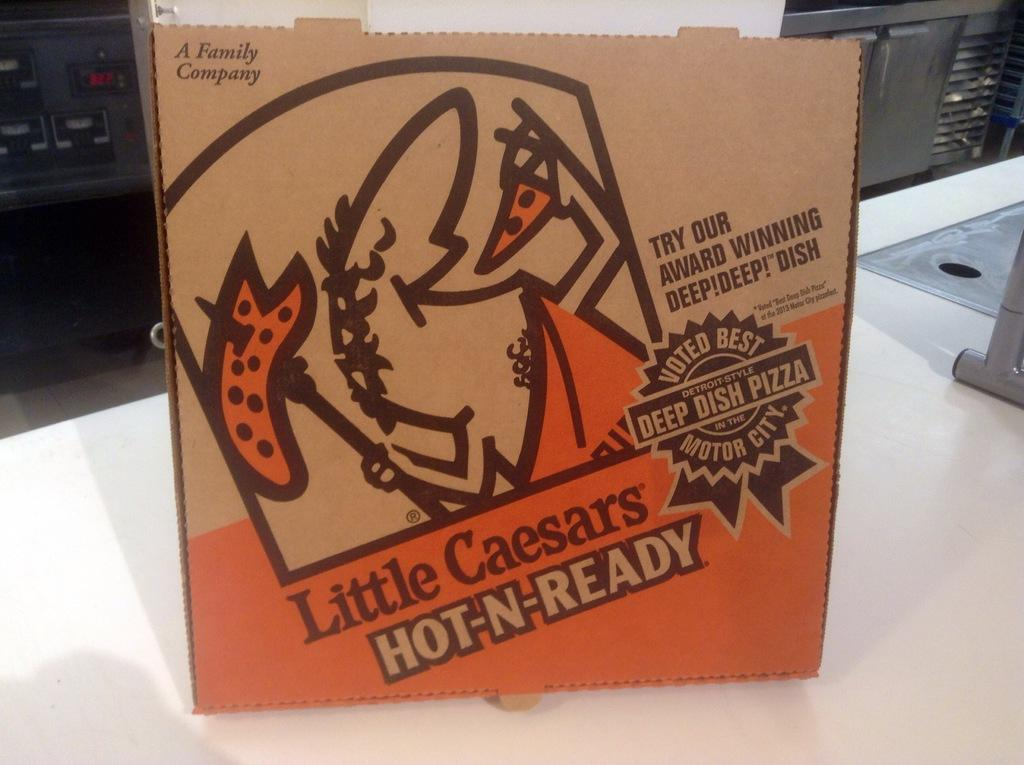<image>
Provide a brief description of the given image. A Little Casesars cardboard pizza box sitting on a counter. 